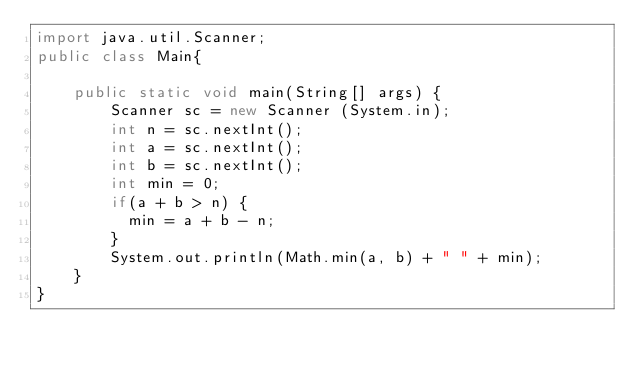Convert code to text. <code><loc_0><loc_0><loc_500><loc_500><_Java_>import java.util.Scanner;
public class Main{
	
    public static void main(String[] args) {
        Scanner sc = new Scanner (System.in);
        int n = sc.nextInt();
        int a = sc.nextInt();
        int b = sc.nextInt();
        int min = 0;
        if(a + b > n) {
        	min = a + b - n;
        }
        System.out.println(Math.min(a, b) + " " + min);
    }
}
</code> 